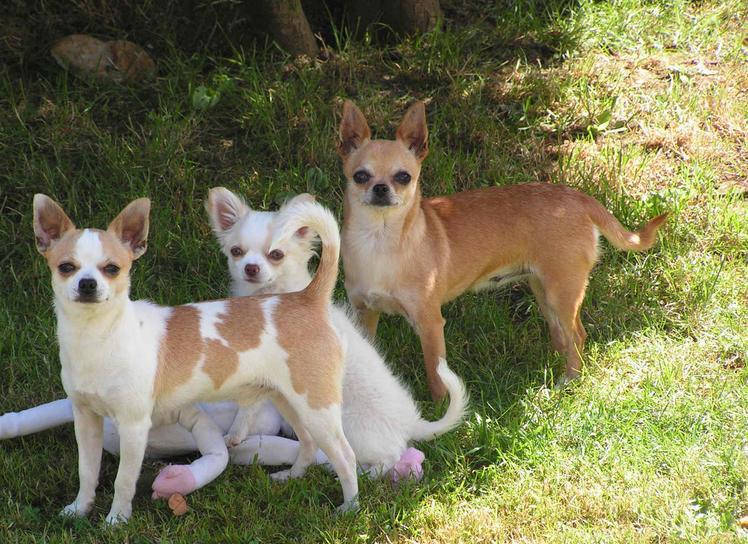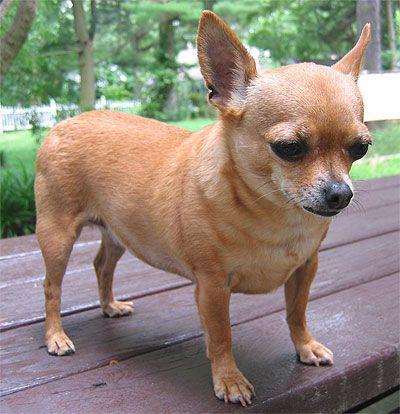The first image is the image on the left, the second image is the image on the right. Examine the images to the left and right. Is the description "The left photo depicts two or more dogs outside in the grass." accurate? Answer yes or no. Yes. The first image is the image on the left, the second image is the image on the right. Analyze the images presented: Is the assertion "There are a total of two dogs between both images." valid? Answer yes or no. No. 